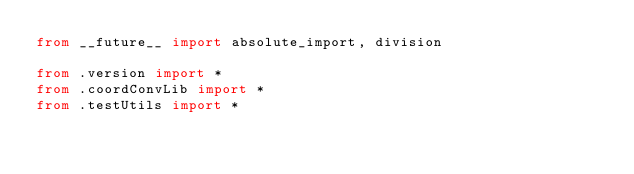<code> <loc_0><loc_0><loc_500><loc_500><_Python_>from __future__ import absolute_import, division

from .version import *
from .coordConvLib import *
from .testUtils import *
</code> 